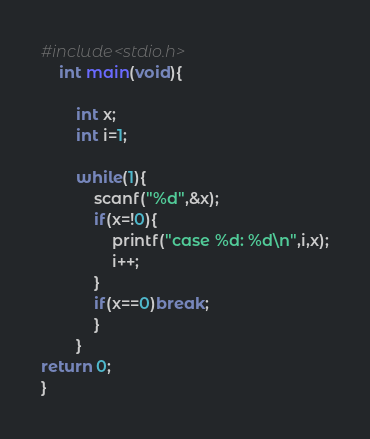<code> <loc_0><loc_0><loc_500><loc_500><_C_>#include<stdio.h>
	int main(void){
		
		int x;
		int i=1;
		
		while(1){
			scanf("%d",&x);
			if(x=!0){
				printf("case %d: %d\n",i,x);
				i++;
			}
			if(x==0)break;
			}
		}
return 0;
}</code> 